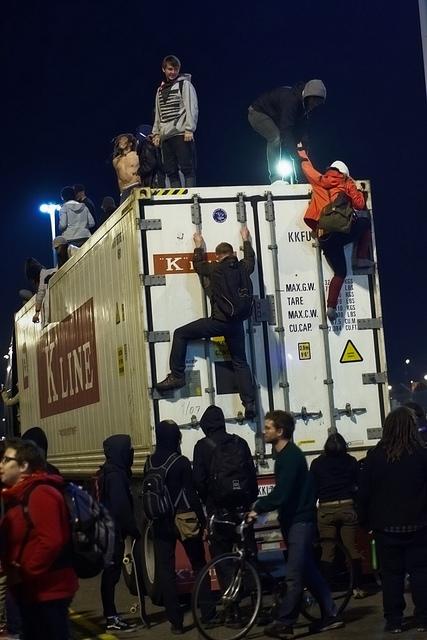Is there a bicycle on top of the truck?
Answer briefly. No. What is the brand on the truck?
Concise answer only. Kline. What color is the truck?
Quick response, please. White. 